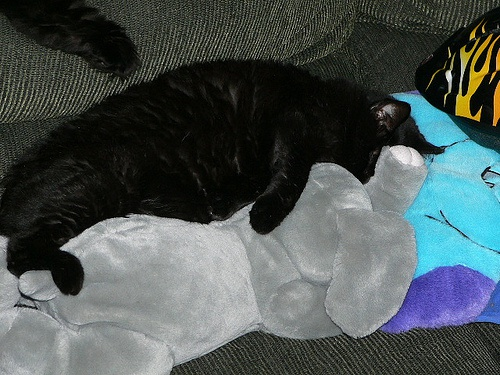Describe the objects in this image and their specific colors. I can see cat in black, darkgray, and gray tones and couch in black, gray, and darkgreen tones in this image. 